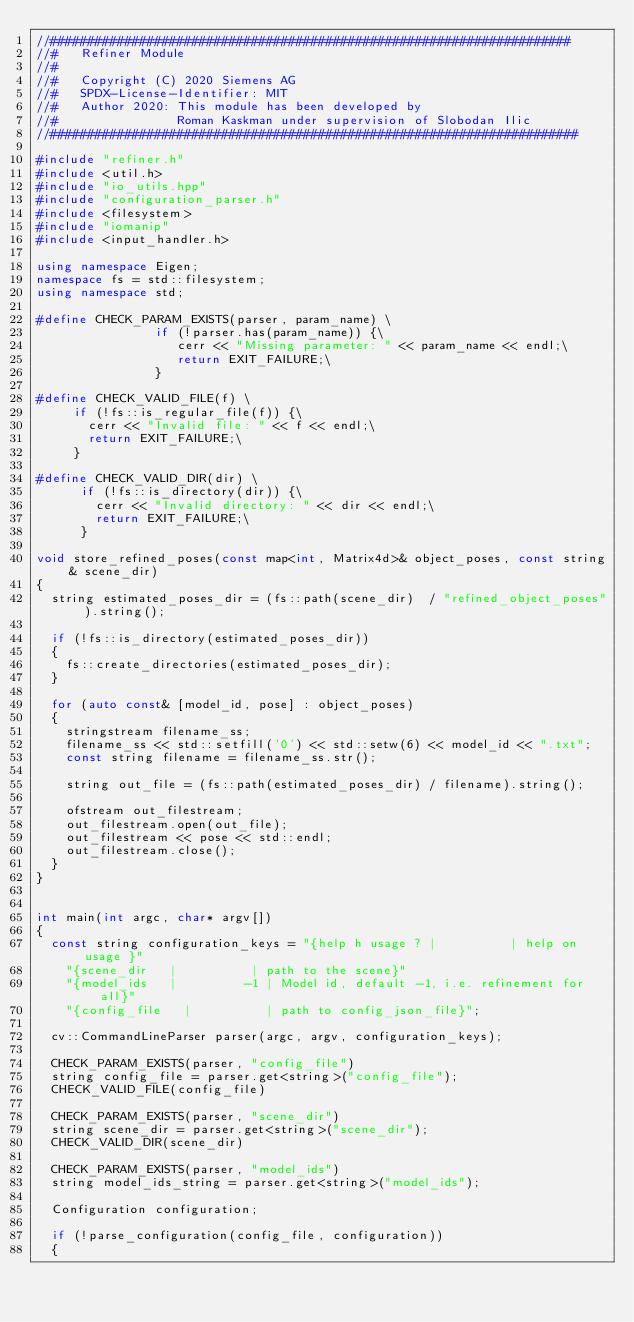<code> <loc_0><loc_0><loc_500><loc_500><_C++_>//######################################################################
//#   Refiner Module 
//#   
//#   Copyright (C) 2020 Siemens AG
//#   SPDX-License-Identifier: MIT
//#   Author 2020: This module has been developed by 
//#                Roman Kaskman under supervision of Slobodan Ilic
//#######################################################################

#include "refiner.h"
#include <util.h>
#include "io_utils.hpp"
#include "configuration_parser.h"
#include <filesystem>
#include "iomanip"
#include <input_handler.h>

using namespace Eigen;
namespace fs = std::filesystem;
using namespace std;

#define CHECK_PARAM_EXISTS(parser, param_name) \
                if (!parser.has(param_name)) {\
                   cerr << "Missing parameter: " << param_name << endl;\
                   return EXIT_FAILURE;\
                }

#define CHECK_VALID_FILE(f) \
     if (!fs::is_regular_file(f)) {\
       cerr << "Invalid file: " << f << endl;\
       return EXIT_FAILURE;\
     }

#define CHECK_VALID_DIR(dir) \
      if (!fs::is_directory(dir)) {\
        cerr << "Invalid directory: " << dir << endl;\
        return EXIT_FAILURE;\
      }

void store_refined_poses(const map<int, Matrix4d>& object_poses, const string& scene_dir)
{
	string estimated_poses_dir = (fs::path(scene_dir)  / "refined_object_poses").string();

	if (!fs::is_directory(estimated_poses_dir))
	{
		fs::create_directories(estimated_poses_dir);
	}

	for (auto const& [model_id, pose] : object_poses)
	{
		stringstream filename_ss;
		filename_ss << std::setfill('0') << std::setw(6) << model_id << ".txt";
		const string filename = filename_ss.str();

		string out_file = (fs::path(estimated_poses_dir) / filename).string();

		ofstream out_filestream;
		out_filestream.open(out_file);
		out_filestream << pose << std::endl;
		out_filestream.close();
	}
}


int main(int argc, char* argv[])
{
	const string configuration_keys = "{help h usage ? |          | help on usage }"
		"{scene_dir   |          | path to the scene}"
		"{model_ids   |         -1 | Model id, default -1, i.e. refinement for all}"
		"{config_file   |          | path to config_json_file}";

	cv::CommandLineParser parser(argc, argv, configuration_keys);

	CHECK_PARAM_EXISTS(parser, "config_file")
	string config_file = parser.get<string>("config_file");
	CHECK_VALID_FILE(config_file)

	CHECK_PARAM_EXISTS(parser, "scene_dir")
	string scene_dir = parser.get<string>("scene_dir");
	CHECK_VALID_DIR(scene_dir)

	CHECK_PARAM_EXISTS(parser, "model_ids")
	string model_ids_string = parser.get<string>("model_ids");

	Configuration configuration;

	if (!parse_configuration(config_file, configuration))
	{</code> 